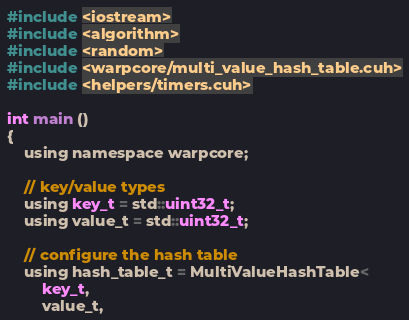Convert code to text. <code><loc_0><loc_0><loc_500><loc_500><_Cuda_>#include <iostream>
#include <algorithm>
#include <random>
#include <warpcore/multi_value_hash_table.cuh>
#include <helpers/timers.cuh>

int main ()
{
    using namespace warpcore;

    // key/value types
    using key_t = std::uint32_t;
    using value_t = std::uint32_t;

    // configure the hash table
    using hash_table_t = MultiValueHashTable<
        key_t,
        value_t,</code> 